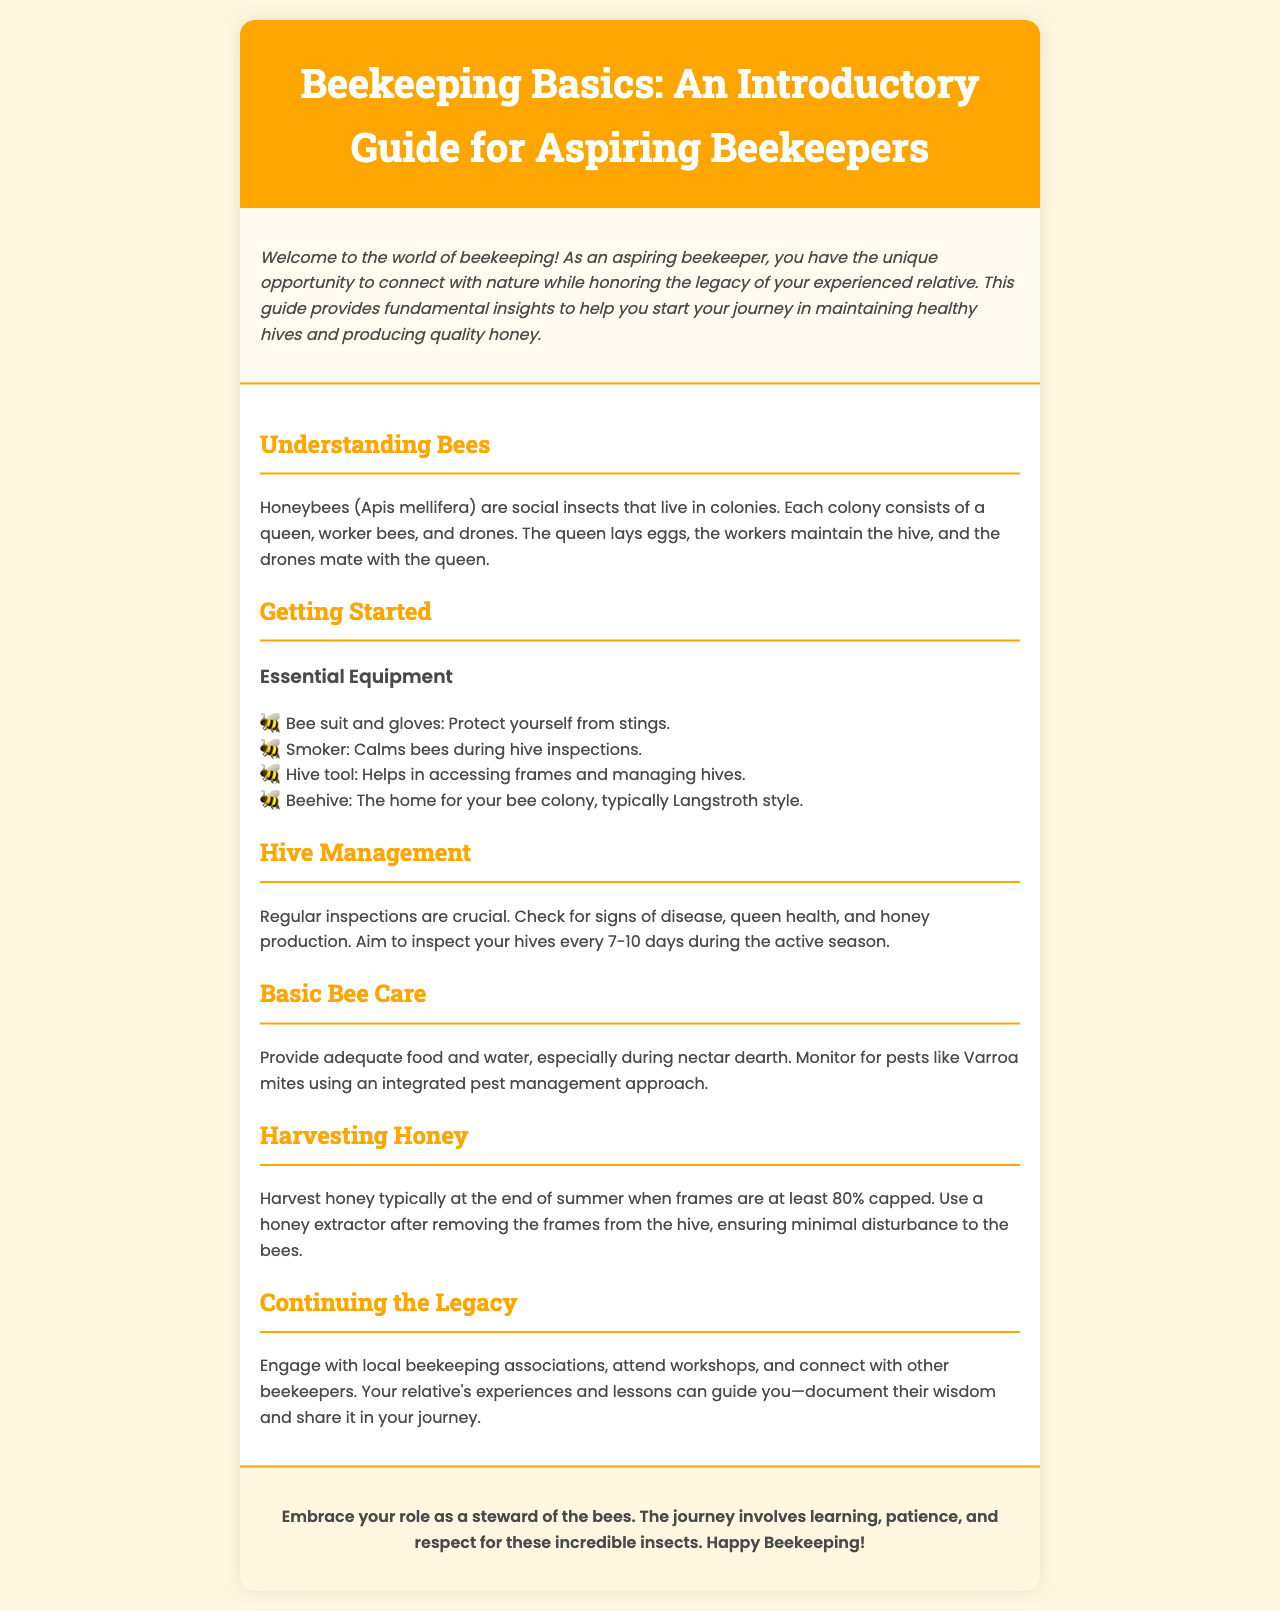What type of insects are honeybees? Honeybees are classified as social insects, as stated in the document.
Answer: Social insects What is included in essential equipment for beekeeping? The document lists essential equipment in a subsection, stating: bee suit and gloves, smoker, hive tool, and beehive.
Answer: Bee suit, smoker, hive tool, beehive How often should you inspect your hives? It is mentioned that inspections should be conducted every 7-10 days during the active season.
Answer: Every 7-10 days What is the purpose of a smoker? The document explains that a smoker calms bees during hive inspections, which is one of its main uses.
Answer: Calms bees When should honey typically be harvested? The document specifies that honey should be harvested at the end of summer when frames are at least 80% capped.
Answer: End of summer What should you monitor for in basic bee care? The document states that you should monitor for pests like Varroa mites.
Answer: Varroa mites What is a suggested way to continue the legacy of beekeeping? Engaging with local beekeeping associations is suggested as a way to continue the legacy.
Answer: Local beekeeping associations What is the main role of the queen bee? The document states that the queen's main role is to lay eggs.
Answer: Lay eggs 